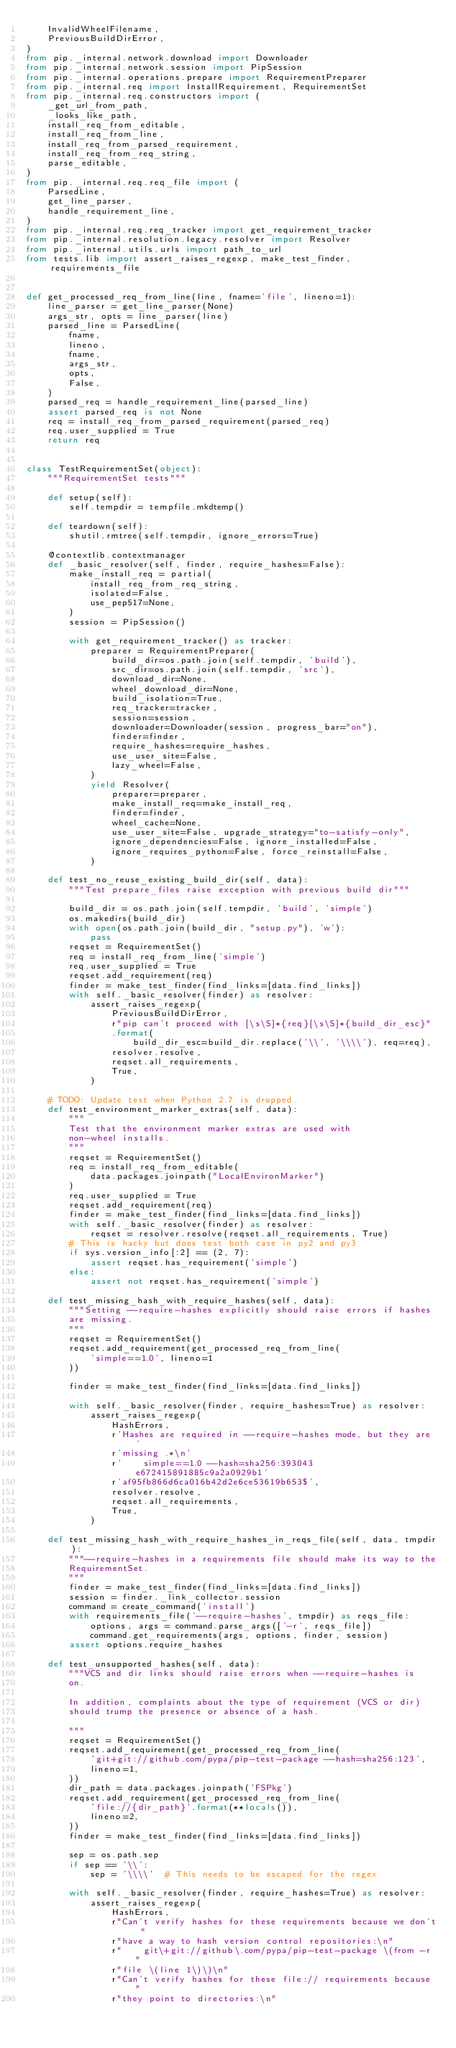Convert code to text. <code><loc_0><loc_0><loc_500><loc_500><_Python_>    InvalidWheelFilename,
    PreviousBuildDirError,
)
from pip._internal.network.download import Downloader
from pip._internal.network.session import PipSession
from pip._internal.operations.prepare import RequirementPreparer
from pip._internal.req import InstallRequirement, RequirementSet
from pip._internal.req.constructors import (
    _get_url_from_path,
    _looks_like_path,
    install_req_from_editable,
    install_req_from_line,
    install_req_from_parsed_requirement,
    install_req_from_req_string,
    parse_editable,
)
from pip._internal.req.req_file import (
    ParsedLine,
    get_line_parser,
    handle_requirement_line,
)
from pip._internal.req.req_tracker import get_requirement_tracker
from pip._internal.resolution.legacy.resolver import Resolver
from pip._internal.utils.urls import path_to_url
from tests.lib import assert_raises_regexp, make_test_finder, requirements_file


def get_processed_req_from_line(line, fname='file', lineno=1):
    line_parser = get_line_parser(None)
    args_str, opts = line_parser(line)
    parsed_line = ParsedLine(
        fname,
        lineno,
        fname,
        args_str,
        opts,
        False,
    )
    parsed_req = handle_requirement_line(parsed_line)
    assert parsed_req is not None
    req = install_req_from_parsed_requirement(parsed_req)
    req.user_supplied = True
    return req


class TestRequirementSet(object):
    """RequirementSet tests"""

    def setup(self):
        self.tempdir = tempfile.mkdtemp()

    def teardown(self):
        shutil.rmtree(self.tempdir, ignore_errors=True)

    @contextlib.contextmanager
    def _basic_resolver(self, finder, require_hashes=False):
        make_install_req = partial(
            install_req_from_req_string,
            isolated=False,
            use_pep517=None,
        )
        session = PipSession()

        with get_requirement_tracker() as tracker:
            preparer = RequirementPreparer(
                build_dir=os.path.join(self.tempdir, 'build'),
                src_dir=os.path.join(self.tempdir, 'src'),
                download_dir=None,
                wheel_download_dir=None,
                build_isolation=True,
                req_tracker=tracker,
                session=session,
                downloader=Downloader(session, progress_bar="on"),
                finder=finder,
                require_hashes=require_hashes,
                use_user_site=False,
                lazy_wheel=False,
            )
            yield Resolver(
                preparer=preparer,
                make_install_req=make_install_req,
                finder=finder,
                wheel_cache=None,
                use_user_site=False, upgrade_strategy="to-satisfy-only",
                ignore_dependencies=False, ignore_installed=False,
                ignore_requires_python=False, force_reinstall=False,
            )

    def test_no_reuse_existing_build_dir(self, data):
        """Test prepare_files raise exception with previous build dir"""

        build_dir = os.path.join(self.tempdir, 'build', 'simple')
        os.makedirs(build_dir)
        with open(os.path.join(build_dir, "setup.py"), 'w'):
            pass
        reqset = RequirementSet()
        req = install_req_from_line('simple')
        req.user_supplied = True
        reqset.add_requirement(req)
        finder = make_test_finder(find_links=[data.find_links])
        with self._basic_resolver(finder) as resolver:
            assert_raises_regexp(
                PreviousBuildDirError,
                r"pip can't proceed with [\s\S]*{req}[\s\S]*{build_dir_esc}"
                .format(
                    build_dir_esc=build_dir.replace('\\', '\\\\'), req=req),
                resolver.resolve,
                reqset.all_requirements,
                True,
            )

    # TODO: Update test when Python 2.7 is dropped.
    def test_environment_marker_extras(self, data):
        """
        Test that the environment marker extras are used with
        non-wheel installs.
        """
        reqset = RequirementSet()
        req = install_req_from_editable(
            data.packages.joinpath("LocalEnvironMarker")
        )
        req.user_supplied = True
        reqset.add_requirement(req)
        finder = make_test_finder(find_links=[data.find_links])
        with self._basic_resolver(finder) as resolver:
            reqset = resolver.resolve(reqset.all_requirements, True)
        # This is hacky but does test both case in py2 and py3
        if sys.version_info[:2] == (2, 7):
            assert reqset.has_requirement('simple')
        else:
            assert not reqset.has_requirement('simple')

    def test_missing_hash_with_require_hashes(self, data):
        """Setting --require-hashes explicitly should raise errors if hashes
        are missing.
        """
        reqset = RequirementSet()
        reqset.add_requirement(get_processed_req_from_line(
            'simple==1.0', lineno=1
        ))

        finder = make_test_finder(find_links=[data.find_links])

        with self._basic_resolver(finder, require_hashes=True) as resolver:
            assert_raises_regexp(
                HashErrors,
                r'Hashes are required in --require-hashes mode, but they are '
                r'missing .*\n'
                r'    simple==1.0 --hash=sha256:393043e672415891885c9a2a0929b1'
                r'af95fb866d6ca016b42d2e6ce53619b653$',
                resolver.resolve,
                reqset.all_requirements,
                True,
            )

    def test_missing_hash_with_require_hashes_in_reqs_file(self, data, tmpdir):
        """--require-hashes in a requirements file should make its way to the
        RequirementSet.
        """
        finder = make_test_finder(find_links=[data.find_links])
        session = finder._link_collector.session
        command = create_command('install')
        with requirements_file('--require-hashes', tmpdir) as reqs_file:
            options, args = command.parse_args(['-r', reqs_file])
            command.get_requirements(args, options, finder, session)
        assert options.require_hashes

    def test_unsupported_hashes(self, data):
        """VCS and dir links should raise errors when --require-hashes is
        on.

        In addition, complaints about the type of requirement (VCS or dir)
        should trump the presence or absence of a hash.

        """
        reqset = RequirementSet()
        reqset.add_requirement(get_processed_req_from_line(
            'git+git://github.com/pypa/pip-test-package --hash=sha256:123',
            lineno=1,
        ))
        dir_path = data.packages.joinpath('FSPkg')
        reqset.add_requirement(get_processed_req_from_line(
            'file://{dir_path}'.format(**locals()),
            lineno=2,
        ))
        finder = make_test_finder(find_links=[data.find_links])

        sep = os.path.sep
        if sep == '\\':
            sep = '\\\\'  # This needs to be escaped for the regex

        with self._basic_resolver(finder, require_hashes=True) as resolver:
            assert_raises_regexp(
                HashErrors,
                r"Can't verify hashes for these requirements because we don't "
                r"have a way to hash version control repositories:\n"
                r"    git\+git://github\.com/pypa/pip-test-package \(from -r "
                r"file \(line 1\)\)\n"
                r"Can't verify hashes for these file:// requirements because "
                r"they point to directories:\n"</code> 